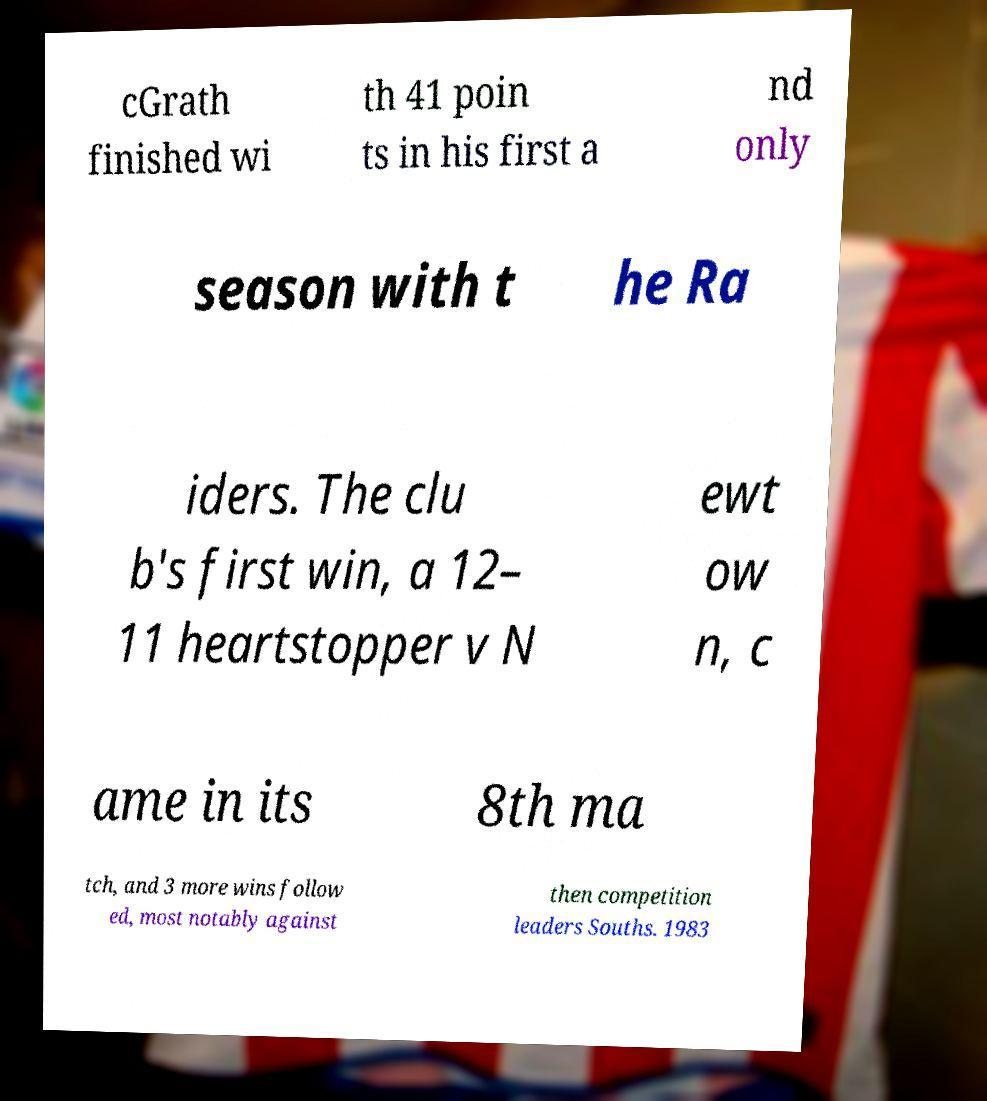Can you read and provide the text displayed in the image?This photo seems to have some interesting text. Can you extract and type it out for me? cGrath finished wi th 41 poin ts in his first a nd only season with t he Ra iders. The clu b's first win, a 12– 11 heartstopper v N ewt ow n, c ame in its 8th ma tch, and 3 more wins follow ed, most notably against then competition leaders Souths. 1983 